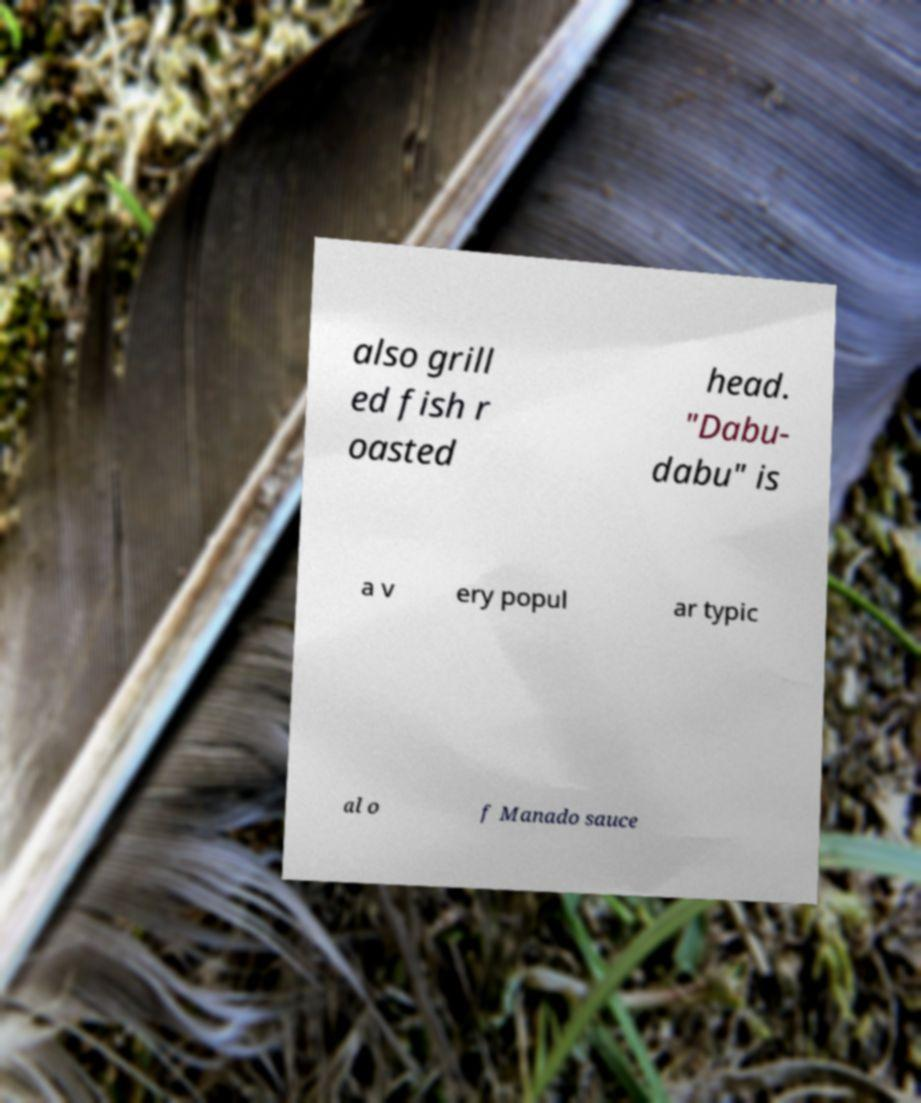Please identify and transcribe the text found in this image. also grill ed fish r oasted head. "Dabu- dabu" is a v ery popul ar typic al o f Manado sauce 